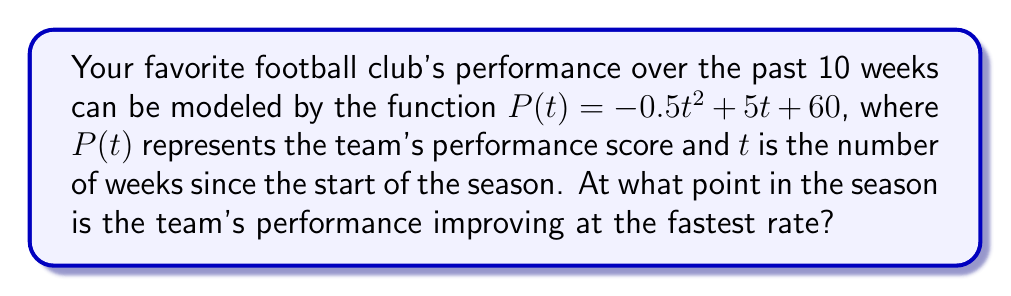Can you answer this question? To solve this problem, we need to follow these steps:

1) The rate of change of the team's performance is given by the derivative of $P(t)$. Let's call this $P'(t)$.

2) To find $P'(t)$, we differentiate $P(t)$:
   $$P'(t) = \frac{d}{dt}(-0.5t^2 + 5t + 60) = -t + 5$$

3) The question asks when the performance is improving at the fastest rate. This occurs when $P'(t)$ is at its maximum value.

4) Since $P'(t)$ is a linear function, its graph is a straight line with a negative slope. The maximum value of a decreasing linear function occurs at the smallest possible value of $t$.

5) In this context, $t$ represents weeks, so the smallest possible value is $t = 0$, which corresponds to the start of the season.

6) To confirm, we can calculate $P'(0)$:
   $$P'(0) = -0 + 5 = 5$$

   This is indeed the maximum value of $P'(t)$ for non-negative $t$.

Therefore, the team's performance is improving at the fastest rate at the very beginning of the season, when $t = 0$.
Answer: $t = 0$ weeks 